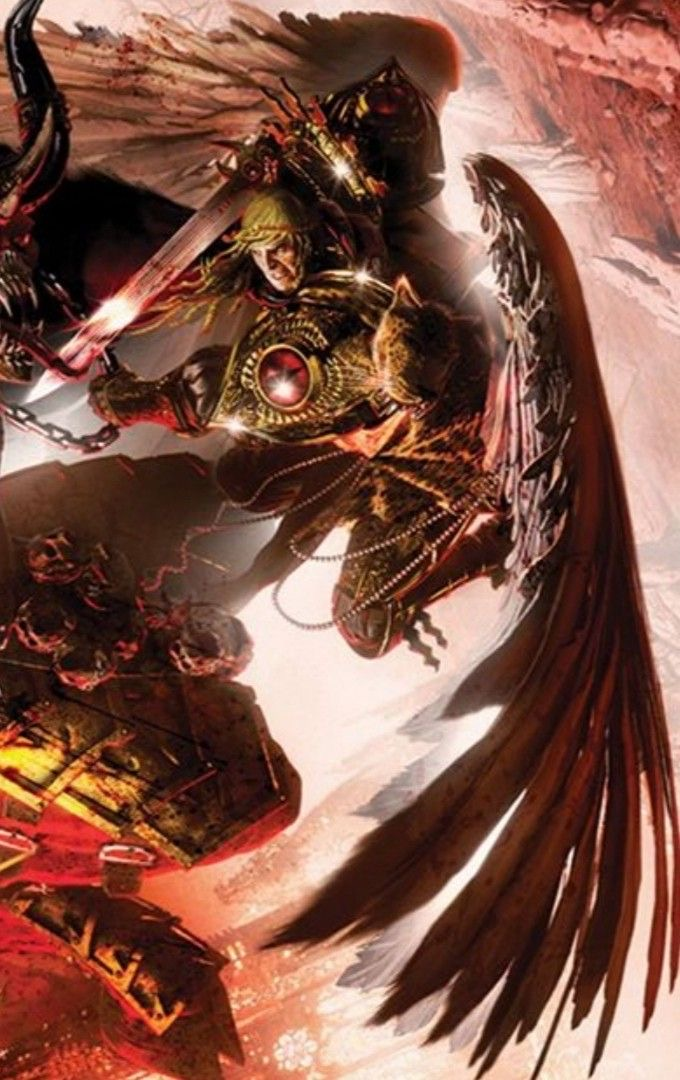describe  This is an image of a fantasy artwork featuring a character that appears to be a warrior or knight. The character is wearing ornate, detailed armor with many gold accents, chains, and a red jewel-like piece at the center of the chest. The helmet has a greenish tint, and there's a face visible underneath, suggesting the character is human or human-like. The armor gives the impression of a high-ranking or royal figure, possibly a character from a fantasy story or game.

The character is wielding a sword with a glowing blade, which adds a magical or mystical element to the overall appearance. Additionally, the character has large, majestic wings that are a mix of feathers and what appears to be metallic or armored segments, implying the ability to fly.

The background of the image is abstract and difficult to discern, but it consists of warm colors like reds and browns, suggesting a tumultuous environment, perhaps a battlefield or a fantastical landscape. The style of the artwork is dynamic and has a sense of motion, with the character seemingly in the midst of action. 